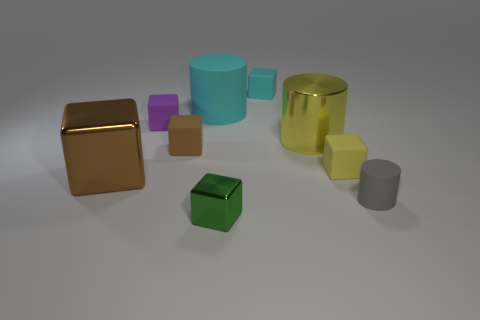What is the cube that is both in front of the yellow matte thing and behind the tiny green cube made of?
Offer a terse response. Metal. There is a big object that is made of the same material as the gray cylinder; what is its shape?
Ensure brevity in your answer.  Cylinder. What number of blocks are on the left side of the tiny purple rubber block behind the brown metal thing?
Make the answer very short. 1. How many matte objects are in front of the brown shiny block and behind the small brown object?
Provide a short and direct response. 0. What number of other things are made of the same material as the small purple cube?
Make the answer very short. 5. What is the color of the cylinder that is to the left of the tiny thing that is in front of the small gray matte cylinder?
Make the answer very short. Cyan. There is a small cube to the right of the large metal cylinder; is it the same color as the large metallic cylinder?
Ensure brevity in your answer.  Yes. Do the gray matte object and the cyan matte block have the same size?
Give a very brief answer. Yes. The gray object that is the same size as the green cube is what shape?
Keep it short and to the point. Cylinder. Is the size of the cube that is right of the cyan block the same as the tiny green cube?
Offer a very short reply. Yes. 